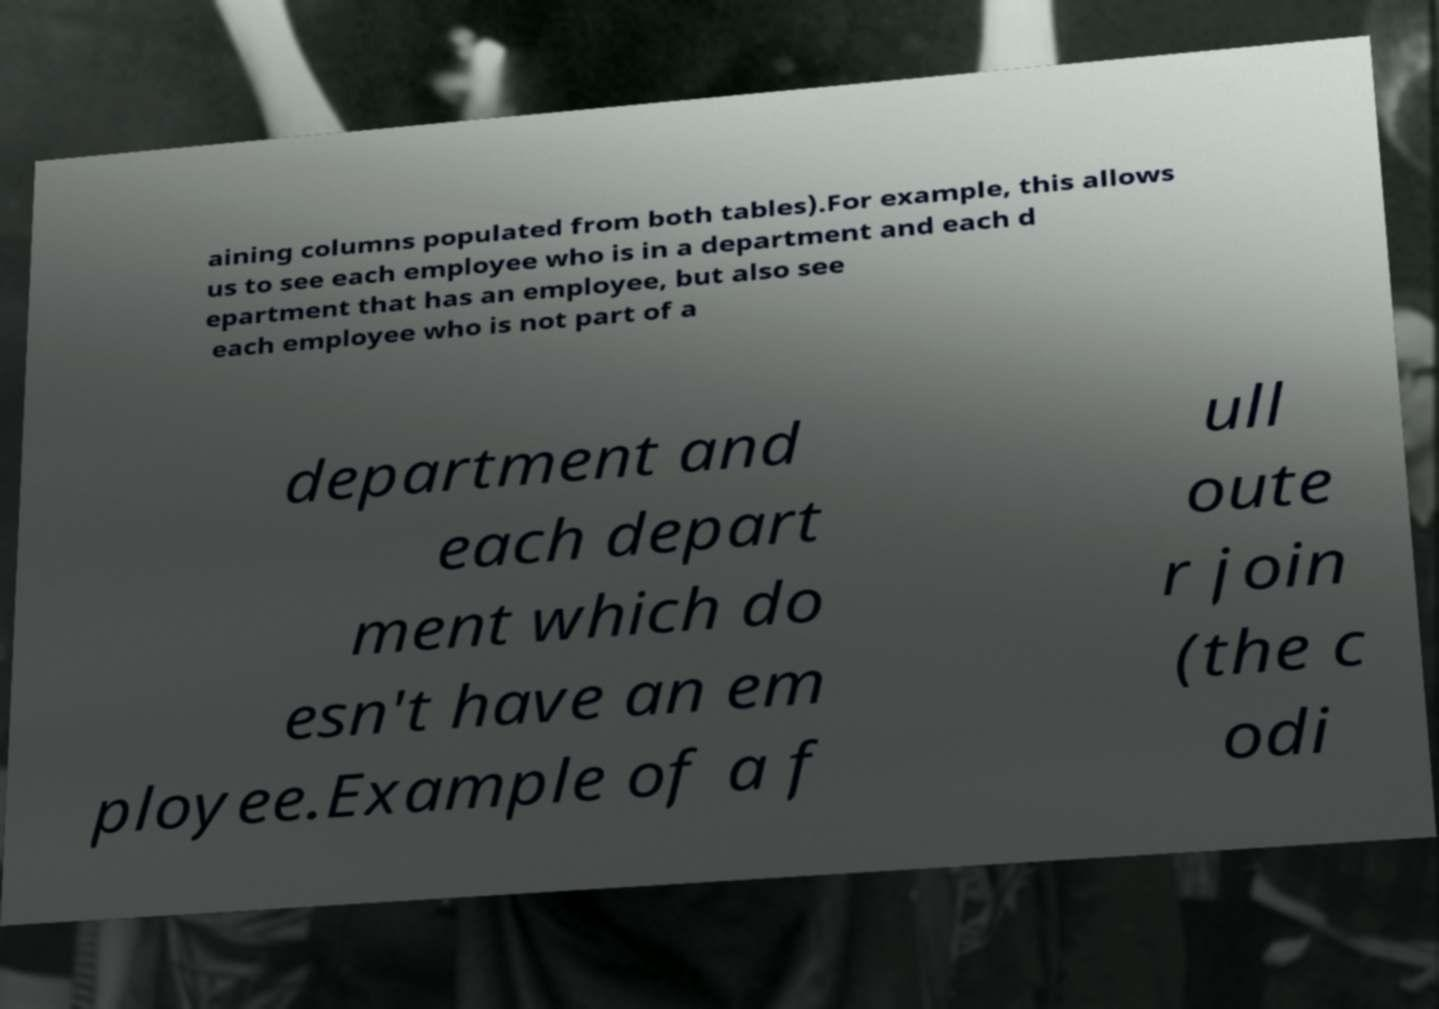Could you extract and type out the text from this image? aining columns populated from both tables).For example, this allows us to see each employee who is in a department and each d epartment that has an employee, but also see each employee who is not part of a department and each depart ment which do esn't have an em ployee.Example of a f ull oute r join (the c odi 